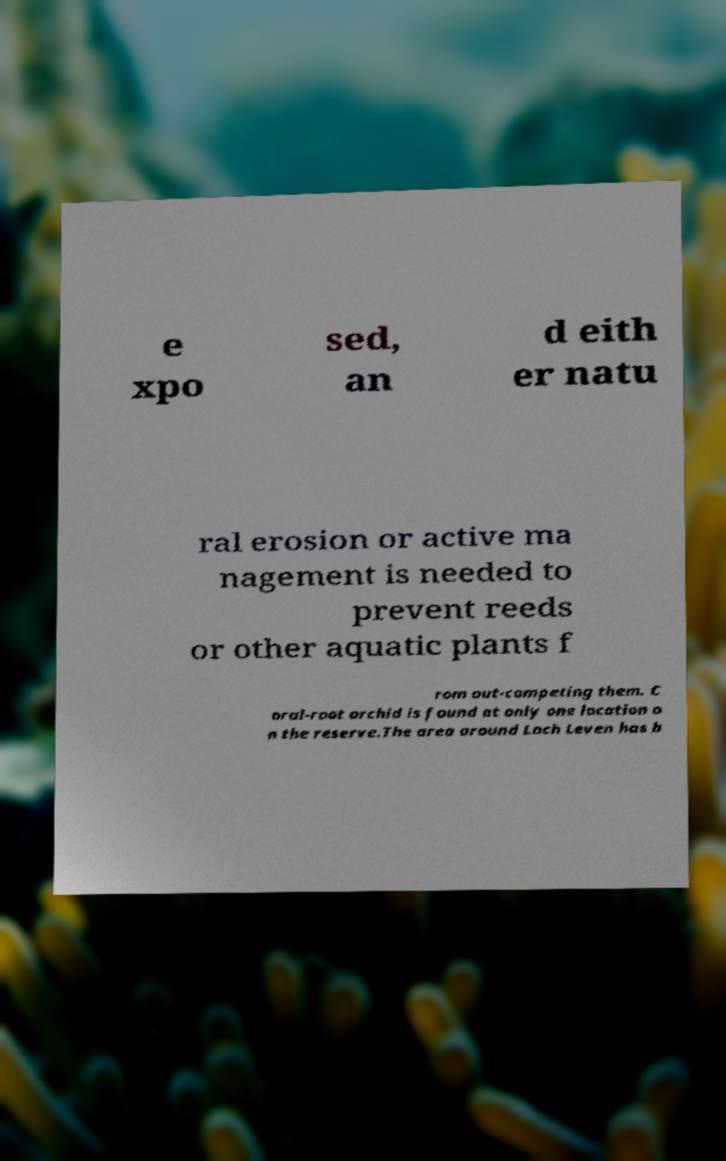Can you read and provide the text displayed in the image?This photo seems to have some interesting text. Can you extract and type it out for me? e xpo sed, an d eith er natu ral erosion or active ma nagement is needed to prevent reeds or other aquatic plants f rom out-competing them. C oral-root orchid is found at only one location o n the reserve.The area around Loch Leven has b 